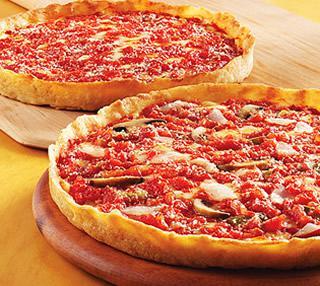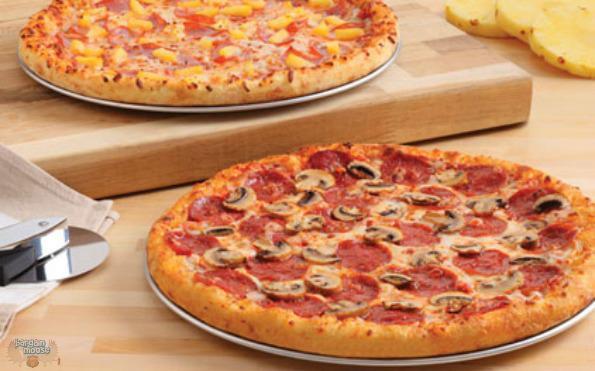The first image is the image on the left, the second image is the image on the right. Considering the images on both sides, is "The left and right image contains the same number of pizzas." valid? Answer yes or no. Yes. The first image is the image on the left, the second image is the image on the right. For the images displayed, is the sentence "One image contains two pizzas and the other image contains one pizza." factually correct? Answer yes or no. No. 